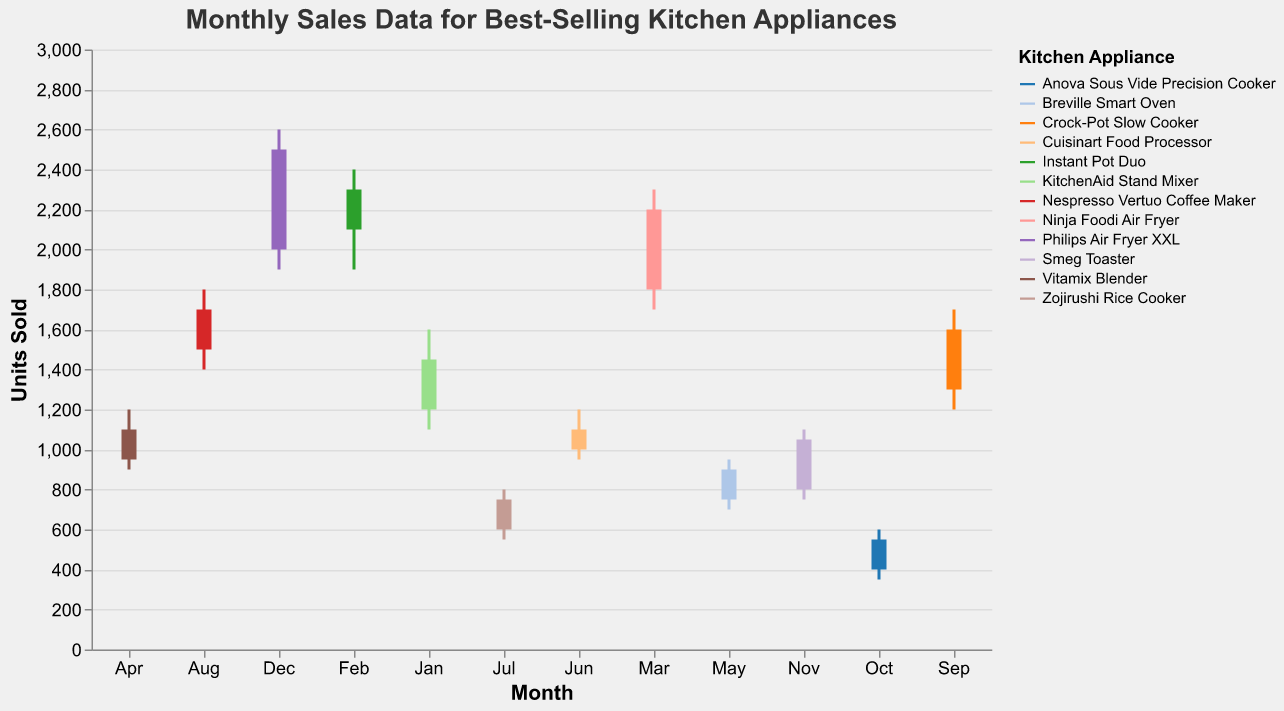Which month had the highest closing units sold for the Philips Air Fryer XXL? Observe the data for each month and appliance, noting the closing units. December shows the highest closing units for the Philips Air Fryer XXL at 2500 units.
Answer: December What is the difference between the maximum and minimum units sold for the Ninja Foodi Air Fryer in March? Find the values for March for the Ninja Foodi Air Fryer. Maximum is 2300 and minimum is 1700. Subtract the minimum from the maximum (2300 - 1700).
Answer: 600 Which appliance had the lowest minimum units sold and in which month? Look at the minimum units sold data for all appliances. The Anova Sous Vide Precision Cooker has the lowest minimum in October with 350 units.
Answer: Anova Sous Vide Precision Cooker, October Did the Instant Pot Duo have an increase or decrease in units sold from its opening to closing in February? For February, compare the opening units (2300) to the closing units (2100) of the Instant Pot Duo. The closing units are fewer than the opening units, indicating a decrease.
Answer: Decrease How many appliances had a closing value higher than 1500 units in any month? Count the appliances where the closing units sold exceed 1500 units. These are KitchenAid Stand Mixer (Jan), Ninja Foodi Air Fryer (Mar), Nespresso Vertuo Coffee Maker (Aug), Crock-Pot Slow Cooker (Sep), and Philips Air Fryer XXL (Dec).
Answer: 5 By how much did the closing units sold in November for Smeg Toaster exceed its opening units? For the Smeg Toaster in November, subtract the opening units (800) from the closing units (1050). The closing units exceed the opening units by 250 units.
Answer: 250 For which months did the Breville Smart Oven have higher closing sales compared to its opening values? Compare the opening and closing values for Breville Smart Oven in May. The closing value (900) is higher than the opening value (750).
Answer: May Which appliance experienced the greatest maximum sales throughout the year? Observe the 'Maximum' column to find the highest value. The Philips Air Fryer XXL had the greatest maximum sales at 2600 units in December.
Answer: Philips Air Fryer XXL What is the average opening sales value across all months for the Anova Sous Vide Precision Cooker? Add the opening values for the Anova Sous Vide Precision Cooker: 400. Since there's only one month (October) in the data, the average is 400/1.
Answer: 400 Which appliance had sales that fluctuated the most in a single month, and by how much? Calculate fluctuations for each appliance by subtracting the minimum from the maximum sales in each month and find the highest. The Philips Air Fryer XXL (Dec) experienced the largest fluctuation: 2600 (maximum) - 1900 (minimum).
Answer: Philips Air Fryer XXL, 700 